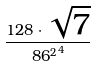Convert formula to latex. <formula><loc_0><loc_0><loc_500><loc_500>\frac { 1 2 8 \cdot \sqrt { 7 } } { { 8 6 ^ { 2 } } ^ { 4 } }</formula> 